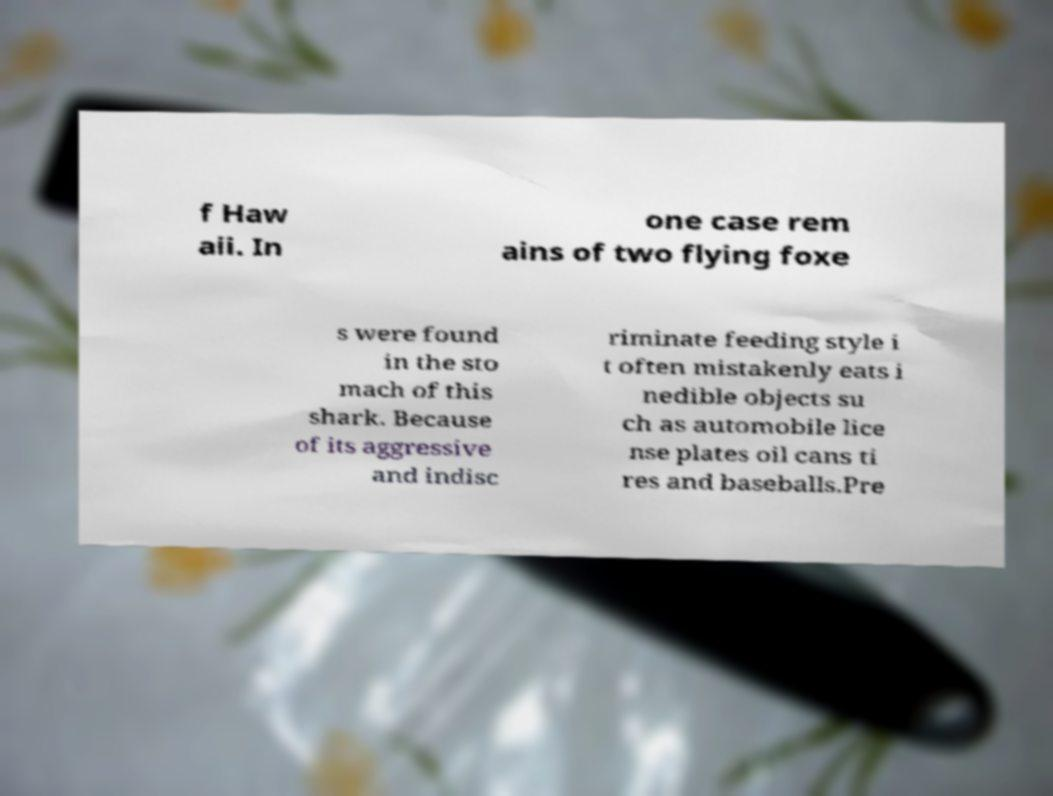Can you accurately transcribe the text from the provided image for me? f Haw aii. In one case rem ains of two flying foxe s were found in the sto mach of this shark. Because of its aggressive and indisc riminate feeding style i t often mistakenly eats i nedible objects su ch as automobile lice nse plates oil cans ti res and baseballs.Pre 